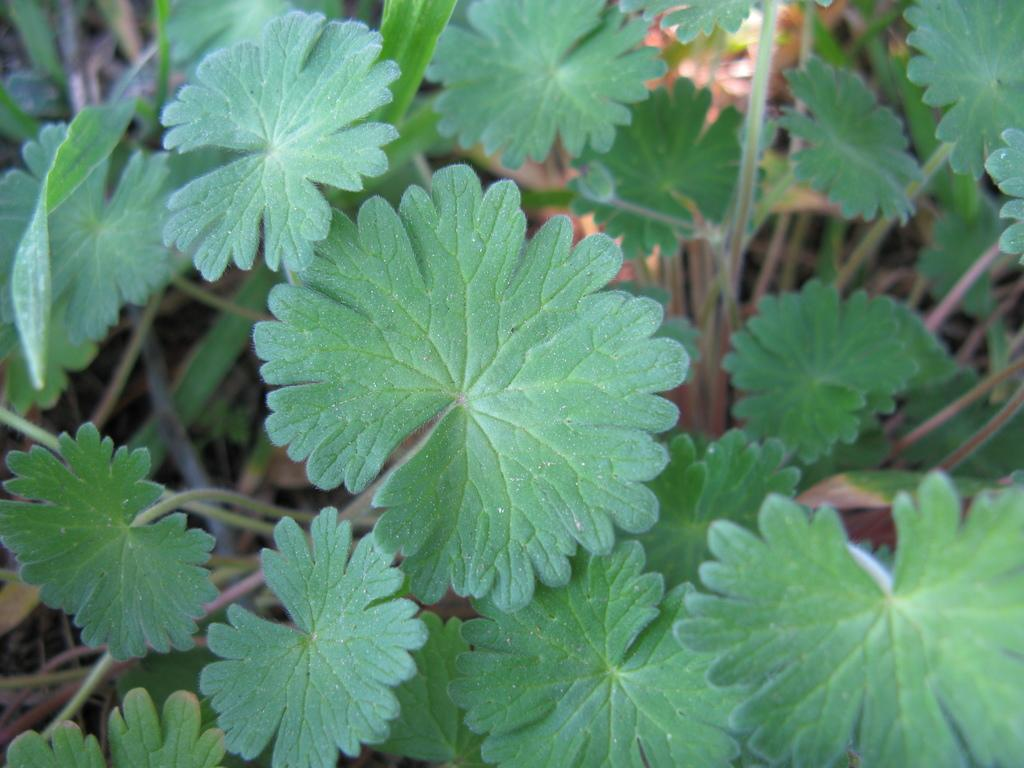What type of vegetation can be seen in the image? There are green color leaves in the image. What else can be observed about the plants in the image? There are stems of the plants in the image. What type of leather material is used to make the lace in the image? There is no leather or lace present in the image; it only features green color leaves and stems of the plants. 